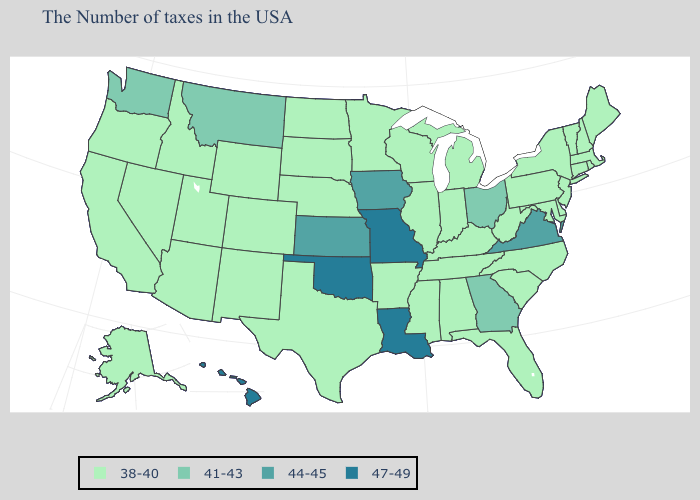What is the value of Indiana?
Write a very short answer. 38-40. Name the states that have a value in the range 44-45?
Quick response, please. Virginia, Iowa, Kansas. Name the states that have a value in the range 41-43?
Keep it brief. Ohio, Georgia, Montana, Washington. Does Arizona have a lower value than Tennessee?
Be succinct. No. What is the highest value in the USA?
Quick response, please. 47-49. Among the states that border Texas , which have the lowest value?
Concise answer only. Arkansas, New Mexico. Name the states that have a value in the range 38-40?
Short answer required. Maine, Massachusetts, Rhode Island, New Hampshire, Vermont, Connecticut, New York, New Jersey, Delaware, Maryland, Pennsylvania, North Carolina, South Carolina, West Virginia, Florida, Michigan, Kentucky, Indiana, Alabama, Tennessee, Wisconsin, Illinois, Mississippi, Arkansas, Minnesota, Nebraska, Texas, South Dakota, North Dakota, Wyoming, Colorado, New Mexico, Utah, Arizona, Idaho, Nevada, California, Oregon, Alaska. What is the lowest value in states that border Arizona?
Concise answer only. 38-40. What is the value of Alabama?
Write a very short answer. 38-40. What is the lowest value in the USA?
Write a very short answer. 38-40. What is the lowest value in the West?
Be succinct. 38-40. Which states have the highest value in the USA?
Keep it brief. Louisiana, Missouri, Oklahoma, Hawaii. What is the value of New York?
Short answer required. 38-40. Does Iowa have a lower value than Missouri?
Give a very brief answer. Yes. 